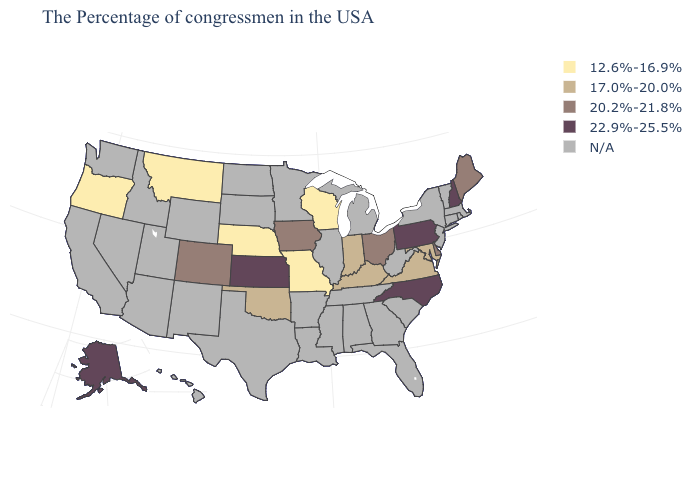What is the highest value in states that border California?
Write a very short answer. 12.6%-16.9%. What is the highest value in the USA?
Write a very short answer. 22.9%-25.5%. How many symbols are there in the legend?
Give a very brief answer. 5. What is the lowest value in states that border Indiana?
Answer briefly. 17.0%-20.0%. Name the states that have a value in the range 17.0%-20.0%?
Write a very short answer. Maryland, Virginia, Kentucky, Indiana, Oklahoma. What is the value of Iowa?
Keep it brief. 20.2%-21.8%. Which states have the highest value in the USA?
Concise answer only. New Hampshire, Pennsylvania, North Carolina, Kansas, Alaska. Which states hav the highest value in the West?
Give a very brief answer. Alaska. Does North Carolina have the highest value in the South?
Write a very short answer. Yes. How many symbols are there in the legend?
Short answer required. 5. What is the highest value in states that border Wisconsin?
Write a very short answer. 20.2%-21.8%. What is the value of Maine?
Answer briefly. 20.2%-21.8%. What is the value of Texas?
Be succinct. N/A. 